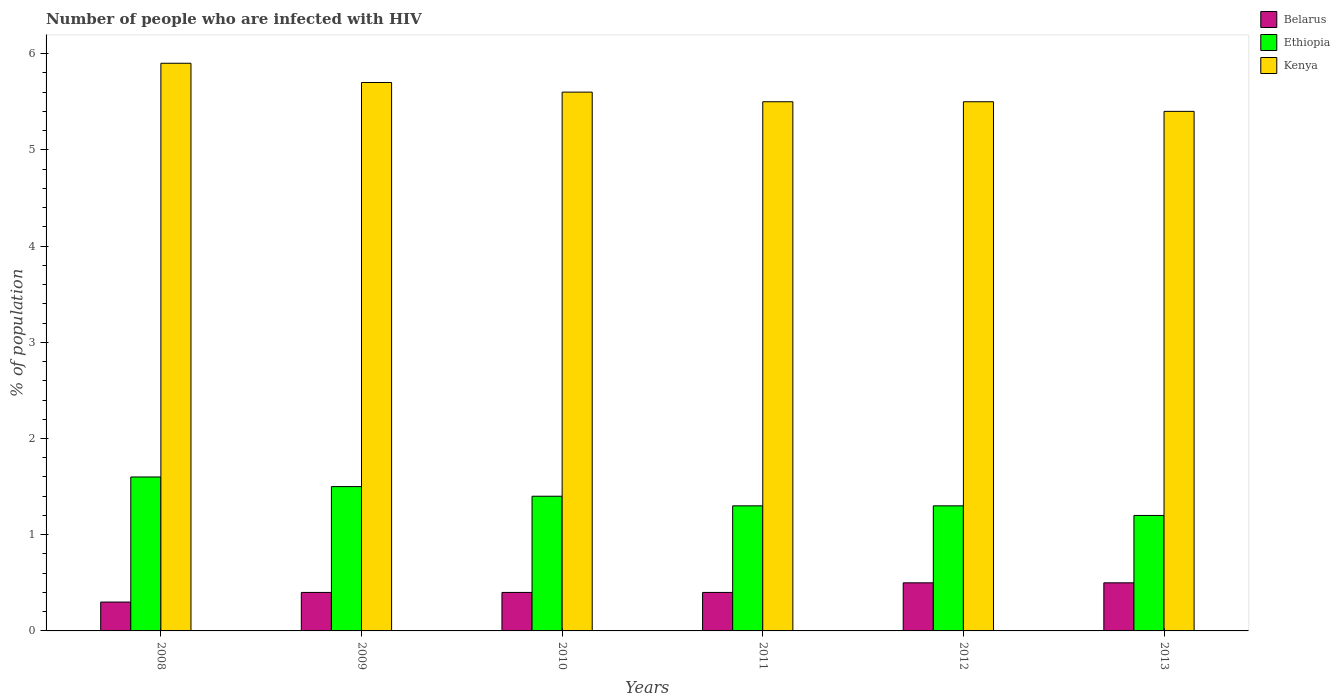How many groups of bars are there?
Provide a short and direct response. 6. Are the number of bars on each tick of the X-axis equal?
Offer a very short reply. Yes. In how many cases, is the number of bars for a given year not equal to the number of legend labels?
Your response must be concise. 0. What is the total percentage of HIV infected population in in Kenya in the graph?
Your answer should be compact. 33.6. What is the difference between the percentage of HIV infected population in in Kenya in 2008 and that in 2011?
Your response must be concise. 0.4. What is the difference between the percentage of HIV infected population in in Belarus in 2011 and the percentage of HIV infected population in in Kenya in 2010?
Your response must be concise. -5.2. What is the average percentage of HIV infected population in in Belarus per year?
Your answer should be compact. 0.42. What is the ratio of the percentage of HIV infected population in in Kenya in 2011 to that in 2013?
Offer a very short reply. 1.02. Is the percentage of HIV infected population in in Belarus in 2008 less than that in 2013?
Give a very brief answer. Yes. Is the difference between the percentage of HIV infected population in in Belarus in 2010 and 2013 greater than the difference between the percentage of HIV infected population in in Kenya in 2010 and 2013?
Your answer should be very brief. No. What is the difference between the highest and the second highest percentage of HIV infected population in in Kenya?
Offer a very short reply. 0.2. What is the difference between the highest and the lowest percentage of HIV infected population in in Ethiopia?
Your answer should be very brief. 0.4. In how many years, is the percentage of HIV infected population in in Belarus greater than the average percentage of HIV infected population in in Belarus taken over all years?
Provide a succinct answer. 2. Is the sum of the percentage of HIV infected population in in Kenya in 2008 and 2011 greater than the maximum percentage of HIV infected population in in Ethiopia across all years?
Ensure brevity in your answer.  Yes. What does the 1st bar from the left in 2011 represents?
Offer a very short reply. Belarus. What does the 1st bar from the right in 2009 represents?
Make the answer very short. Kenya. How many bars are there?
Make the answer very short. 18. Are all the bars in the graph horizontal?
Provide a short and direct response. No. What is the difference between two consecutive major ticks on the Y-axis?
Your answer should be compact. 1. Are the values on the major ticks of Y-axis written in scientific E-notation?
Offer a very short reply. No. Does the graph contain any zero values?
Keep it short and to the point. No. Does the graph contain grids?
Provide a short and direct response. No. What is the title of the graph?
Keep it short and to the point. Number of people who are infected with HIV. What is the label or title of the Y-axis?
Your response must be concise. % of population. What is the % of population in Kenya in 2008?
Your answer should be compact. 5.9. What is the % of population in Ethiopia in 2009?
Your response must be concise. 1.5. What is the % of population in Kenya in 2009?
Offer a terse response. 5.7. What is the % of population of Belarus in 2010?
Ensure brevity in your answer.  0.4. What is the % of population of Ethiopia in 2010?
Your answer should be very brief. 1.4. What is the % of population of Ethiopia in 2011?
Provide a succinct answer. 1.3. What is the % of population of Belarus in 2012?
Give a very brief answer. 0.5. What is the % of population in Kenya in 2013?
Make the answer very short. 5.4. Across all years, what is the minimum % of population in Belarus?
Your answer should be very brief. 0.3. Across all years, what is the minimum % of population of Kenya?
Give a very brief answer. 5.4. What is the total % of population in Ethiopia in the graph?
Provide a succinct answer. 8.3. What is the total % of population in Kenya in the graph?
Provide a short and direct response. 33.6. What is the difference between the % of population of Belarus in 2008 and that in 2009?
Offer a very short reply. -0.1. What is the difference between the % of population in Ethiopia in 2008 and that in 2010?
Offer a terse response. 0.2. What is the difference between the % of population in Kenya in 2008 and that in 2010?
Keep it short and to the point. 0.3. What is the difference between the % of population in Kenya in 2008 and that in 2011?
Offer a terse response. 0.4. What is the difference between the % of population in Kenya in 2008 and that in 2013?
Make the answer very short. 0.5. What is the difference between the % of population of Ethiopia in 2009 and that in 2010?
Offer a terse response. 0.1. What is the difference between the % of population of Kenya in 2009 and that in 2010?
Your answer should be compact. 0.1. What is the difference between the % of population in Belarus in 2009 and that in 2011?
Your answer should be very brief. 0. What is the difference between the % of population in Belarus in 2009 and that in 2013?
Make the answer very short. -0.1. What is the difference between the % of population in Belarus in 2010 and that in 2011?
Provide a short and direct response. 0. What is the difference between the % of population of Ethiopia in 2010 and that in 2011?
Ensure brevity in your answer.  0.1. What is the difference between the % of population in Kenya in 2010 and that in 2011?
Give a very brief answer. 0.1. What is the difference between the % of population of Belarus in 2010 and that in 2012?
Make the answer very short. -0.1. What is the difference between the % of population of Kenya in 2010 and that in 2012?
Your response must be concise. 0.1. What is the difference between the % of population in Kenya in 2010 and that in 2013?
Make the answer very short. 0.2. What is the difference between the % of population of Belarus in 2011 and that in 2012?
Ensure brevity in your answer.  -0.1. What is the difference between the % of population in Belarus in 2011 and that in 2013?
Offer a very short reply. -0.1. What is the difference between the % of population of Belarus in 2012 and that in 2013?
Make the answer very short. 0. What is the difference between the % of population in Ethiopia in 2012 and that in 2013?
Ensure brevity in your answer.  0.1. What is the difference between the % of population of Kenya in 2012 and that in 2013?
Provide a short and direct response. 0.1. What is the difference between the % of population of Belarus in 2008 and the % of population of Ethiopia in 2010?
Ensure brevity in your answer.  -1.1. What is the difference between the % of population in Belarus in 2008 and the % of population in Kenya in 2010?
Your answer should be compact. -5.3. What is the difference between the % of population in Belarus in 2008 and the % of population in Ethiopia in 2011?
Provide a succinct answer. -1. What is the difference between the % of population of Belarus in 2008 and the % of population of Kenya in 2012?
Keep it short and to the point. -5.2. What is the difference between the % of population in Belarus in 2009 and the % of population in Ethiopia in 2010?
Provide a succinct answer. -1. What is the difference between the % of population of Belarus in 2009 and the % of population of Kenya in 2011?
Make the answer very short. -5.1. What is the difference between the % of population of Ethiopia in 2009 and the % of population of Kenya in 2011?
Your response must be concise. -4. What is the difference between the % of population in Ethiopia in 2009 and the % of population in Kenya in 2012?
Make the answer very short. -4. What is the difference between the % of population of Belarus in 2009 and the % of population of Ethiopia in 2013?
Ensure brevity in your answer.  -0.8. What is the difference between the % of population in Belarus in 2009 and the % of population in Kenya in 2013?
Your answer should be very brief. -5. What is the difference between the % of population of Belarus in 2010 and the % of population of Ethiopia in 2011?
Keep it short and to the point. -0.9. What is the difference between the % of population in Belarus in 2010 and the % of population in Kenya in 2011?
Make the answer very short. -5.1. What is the difference between the % of population in Ethiopia in 2010 and the % of population in Kenya in 2012?
Provide a succinct answer. -4.1. What is the difference between the % of population in Belarus in 2010 and the % of population in Ethiopia in 2013?
Ensure brevity in your answer.  -0.8. What is the difference between the % of population in Belarus in 2011 and the % of population in Kenya in 2012?
Provide a succinct answer. -5.1. What is the difference between the % of population of Belarus in 2011 and the % of population of Ethiopia in 2013?
Your response must be concise. -0.8. What is the difference between the % of population of Ethiopia in 2011 and the % of population of Kenya in 2013?
Keep it short and to the point. -4.1. What is the average % of population of Belarus per year?
Your response must be concise. 0.42. What is the average % of population of Ethiopia per year?
Keep it short and to the point. 1.38. In the year 2008, what is the difference between the % of population of Belarus and % of population of Kenya?
Keep it short and to the point. -5.6. In the year 2008, what is the difference between the % of population in Ethiopia and % of population in Kenya?
Ensure brevity in your answer.  -4.3. In the year 2009, what is the difference between the % of population in Belarus and % of population in Ethiopia?
Provide a succinct answer. -1.1. In the year 2009, what is the difference between the % of population of Belarus and % of population of Kenya?
Your response must be concise. -5.3. In the year 2009, what is the difference between the % of population of Ethiopia and % of population of Kenya?
Ensure brevity in your answer.  -4.2. In the year 2010, what is the difference between the % of population in Belarus and % of population in Ethiopia?
Ensure brevity in your answer.  -1. In the year 2011, what is the difference between the % of population of Belarus and % of population of Ethiopia?
Provide a short and direct response. -0.9. In the year 2011, what is the difference between the % of population in Belarus and % of population in Kenya?
Make the answer very short. -5.1. In the year 2012, what is the difference between the % of population of Belarus and % of population of Ethiopia?
Offer a terse response. -0.8. In the year 2012, what is the difference between the % of population of Belarus and % of population of Kenya?
Provide a succinct answer. -5. In the year 2013, what is the difference between the % of population of Belarus and % of population of Ethiopia?
Offer a very short reply. -0.7. In the year 2013, what is the difference between the % of population of Belarus and % of population of Kenya?
Your response must be concise. -4.9. In the year 2013, what is the difference between the % of population in Ethiopia and % of population in Kenya?
Give a very brief answer. -4.2. What is the ratio of the % of population in Belarus in 2008 to that in 2009?
Your response must be concise. 0.75. What is the ratio of the % of population in Ethiopia in 2008 to that in 2009?
Provide a succinct answer. 1.07. What is the ratio of the % of population in Kenya in 2008 to that in 2009?
Ensure brevity in your answer.  1.04. What is the ratio of the % of population in Belarus in 2008 to that in 2010?
Provide a succinct answer. 0.75. What is the ratio of the % of population in Kenya in 2008 to that in 2010?
Give a very brief answer. 1.05. What is the ratio of the % of population in Ethiopia in 2008 to that in 2011?
Your answer should be compact. 1.23. What is the ratio of the % of population of Kenya in 2008 to that in 2011?
Make the answer very short. 1.07. What is the ratio of the % of population in Belarus in 2008 to that in 2012?
Offer a very short reply. 0.6. What is the ratio of the % of population in Ethiopia in 2008 to that in 2012?
Your answer should be compact. 1.23. What is the ratio of the % of population in Kenya in 2008 to that in 2012?
Your answer should be compact. 1.07. What is the ratio of the % of population in Ethiopia in 2008 to that in 2013?
Your answer should be compact. 1.33. What is the ratio of the % of population in Kenya in 2008 to that in 2013?
Offer a terse response. 1.09. What is the ratio of the % of population of Ethiopia in 2009 to that in 2010?
Offer a terse response. 1.07. What is the ratio of the % of population in Kenya in 2009 to that in 2010?
Offer a terse response. 1.02. What is the ratio of the % of population in Belarus in 2009 to that in 2011?
Your answer should be compact. 1. What is the ratio of the % of population in Ethiopia in 2009 to that in 2011?
Your answer should be compact. 1.15. What is the ratio of the % of population of Kenya in 2009 to that in 2011?
Your answer should be very brief. 1.04. What is the ratio of the % of population of Ethiopia in 2009 to that in 2012?
Your answer should be very brief. 1.15. What is the ratio of the % of population in Kenya in 2009 to that in 2012?
Offer a very short reply. 1.04. What is the ratio of the % of population in Kenya in 2009 to that in 2013?
Keep it short and to the point. 1.06. What is the ratio of the % of population of Ethiopia in 2010 to that in 2011?
Provide a short and direct response. 1.08. What is the ratio of the % of population of Kenya in 2010 to that in 2011?
Provide a short and direct response. 1.02. What is the ratio of the % of population of Kenya in 2010 to that in 2012?
Offer a very short reply. 1.02. What is the ratio of the % of population in Belarus in 2010 to that in 2013?
Ensure brevity in your answer.  0.8. What is the ratio of the % of population of Ethiopia in 2011 to that in 2012?
Offer a very short reply. 1. What is the ratio of the % of population of Belarus in 2011 to that in 2013?
Give a very brief answer. 0.8. What is the ratio of the % of population of Kenya in 2011 to that in 2013?
Your answer should be very brief. 1.02. What is the ratio of the % of population in Ethiopia in 2012 to that in 2013?
Make the answer very short. 1.08. What is the ratio of the % of population of Kenya in 2012 to that in 2013?
Ensure brevity in your answer.  1.02. What is the difference between the highest and the second highest % of population in Belarus?
Your answer should be compact. 0. What is the difference between the highest and the second highest % of population of Ethiopia?
Offer a very short reply. 0.1. 